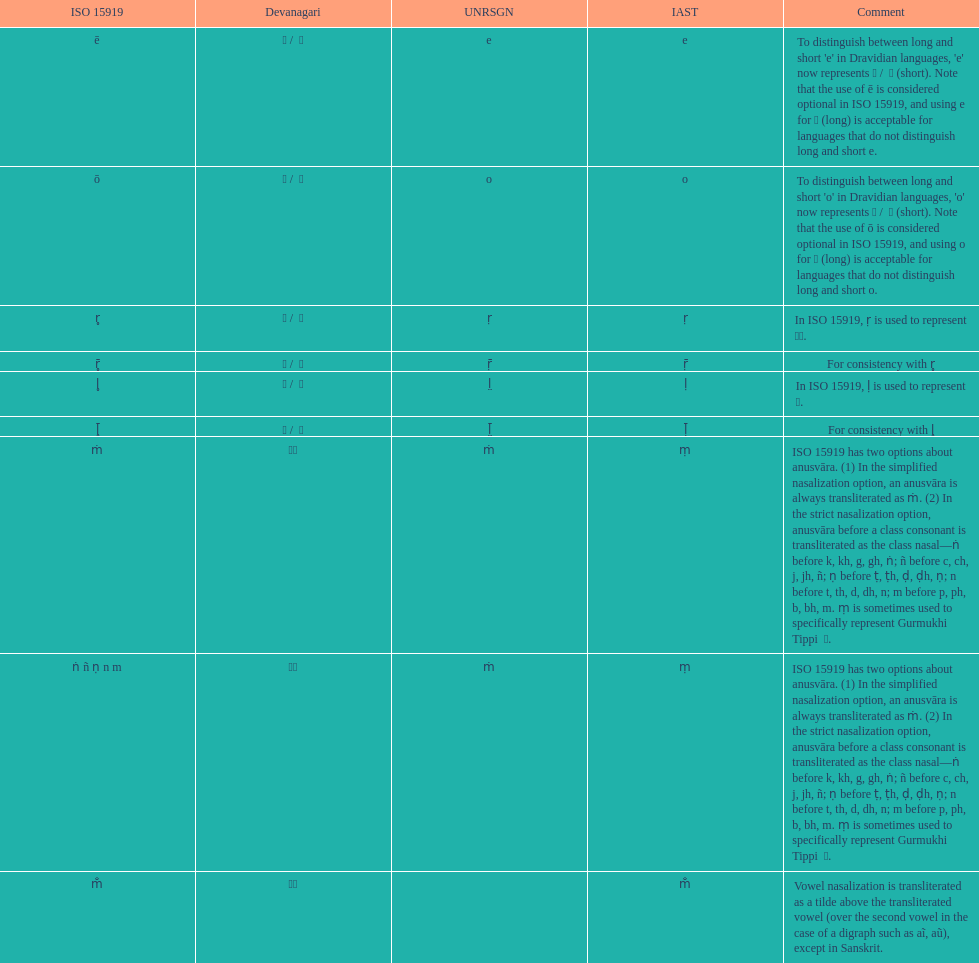What is listed previous to in iso 15919, &#7735; is used to represent &#2355;. under comments? For consistency with r̥. 